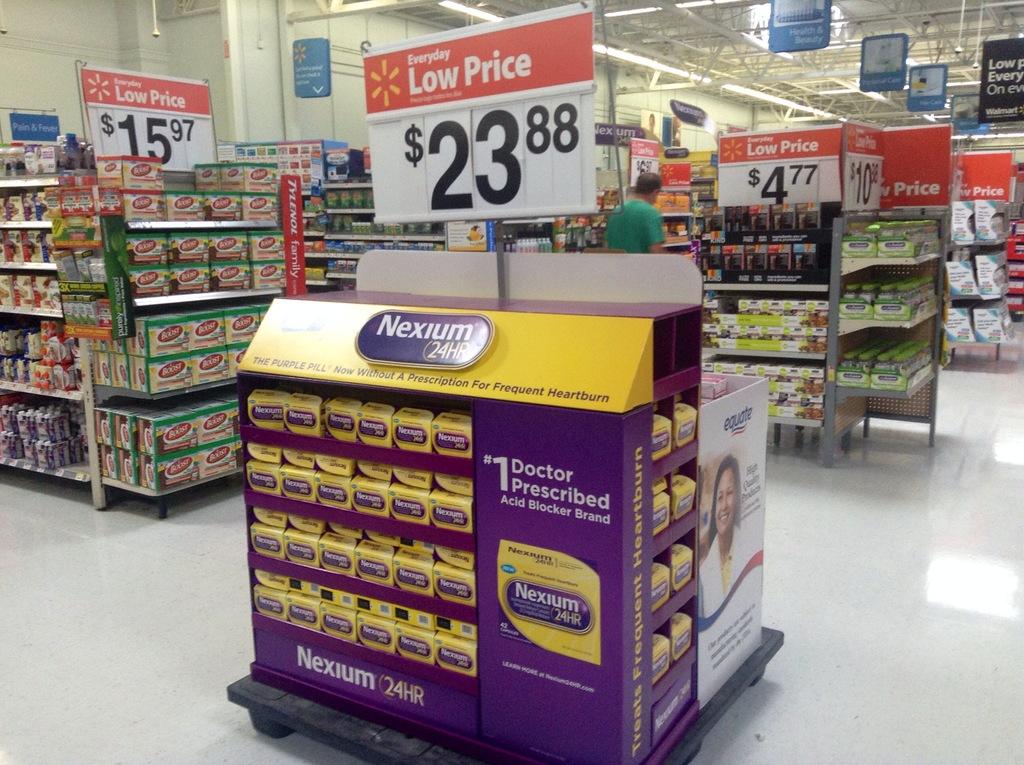What is the name of the medicine that cost $23.88?
Your answer should be very brief. Nexium. What ranking is the medicine by doctor prescription?
Offer a terse response. #1. 